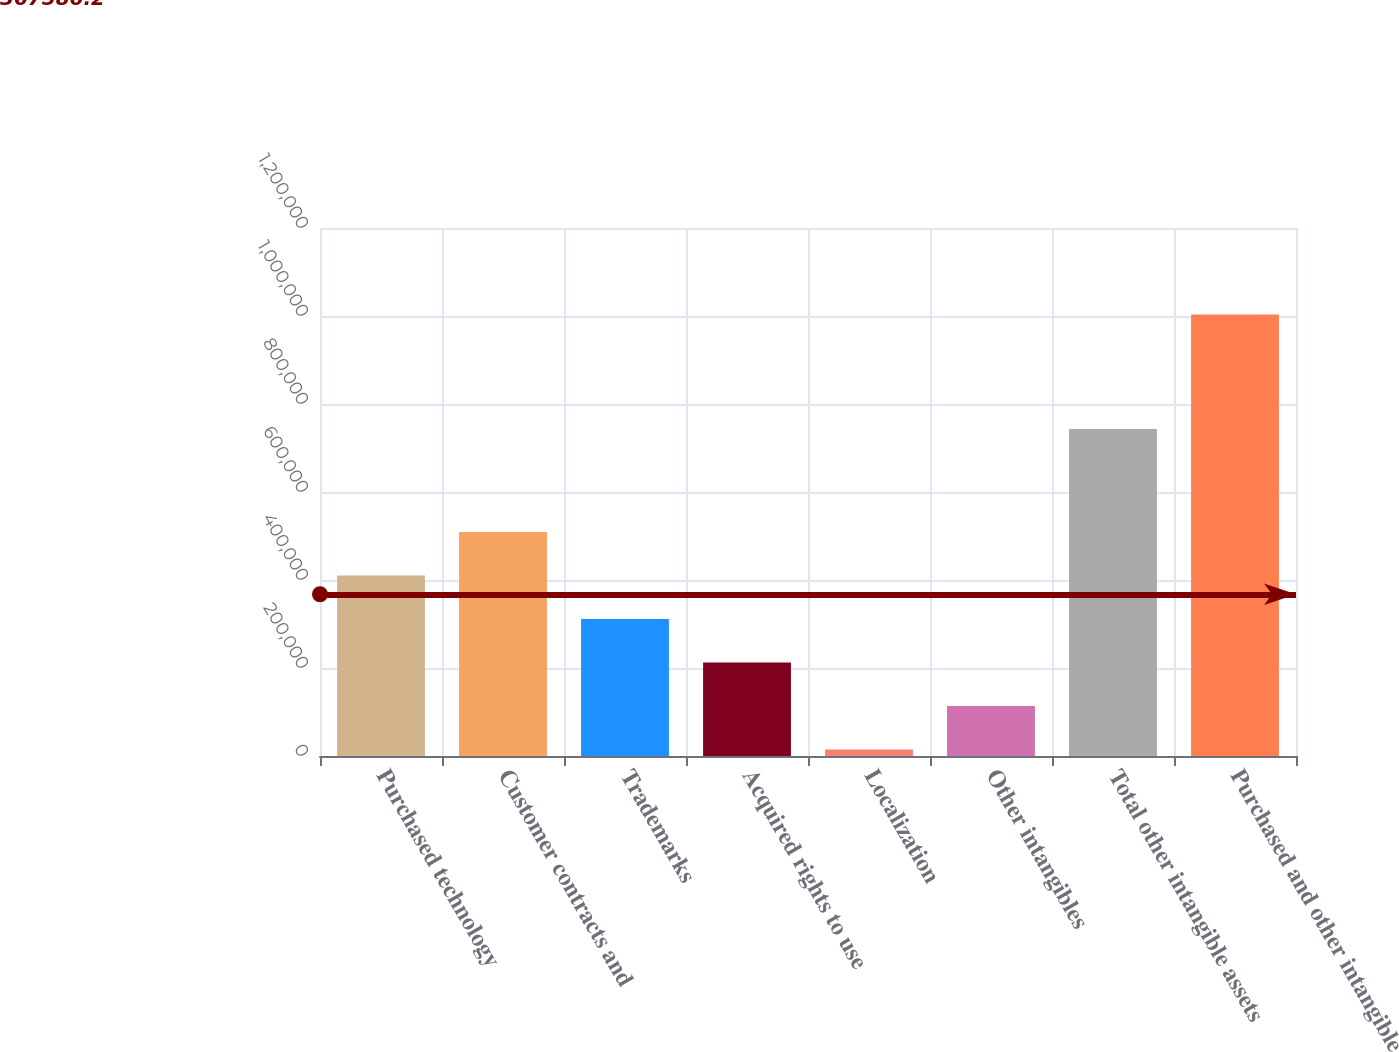<chart> <loc_0><loc_0><loc_500><loc_500><bar_chart><fcel>Purchased technology<fcel>Customer contracts and<fcel>Trademarks<fcel>Acquired rights to use<fcel>Localization<fcel>Other intangibles<fcel>Total other intangible assets<fcel>Purchased and other intangible<nl><fcel>410290<fcel>509170<fcel>311410<fcel>212529<fcel>14768<fcel>113648<fcel>743375<fcel>1.00357e+06<nl></chart> 